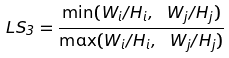Convert formula to latex. <formula><loc_0><loc_0><loc_500><loc_500>L S _ { 3 } = \frac { \min ( W _ { i } / H _ { i } , \ W _ { j } / H _ { j } ) } { \max ( W _ { i } / H _ { i } , \ W _ { j } / H _ { j } ) }</formula> 